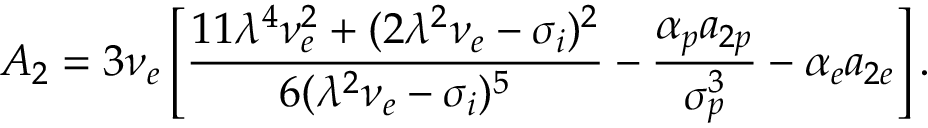Convert formula to latex. <formula><loc_0><loc_0><loc_500><loc_500>A _ { 2 } = 3 \nu _ { e } \left [ \frac { 1 1 \lambda ^ { 4 } \nu _ { e } ^ { 2 } + ( 2 \lambda ^ { 2 } \nu _ { e } - \sigma _ { i } ) ^ { 2 } } { 6 ( \lambda ^ { 2 } \nu _ { e } - \sigma _ { i } ) ^ { 5 } } - \frac { \alpha _ { p } a _ { 2 p } } { \sigma _ { p } ^ { 3 } } - \alpha _ { e } a _ { 2 e } \right ] .</formula> 